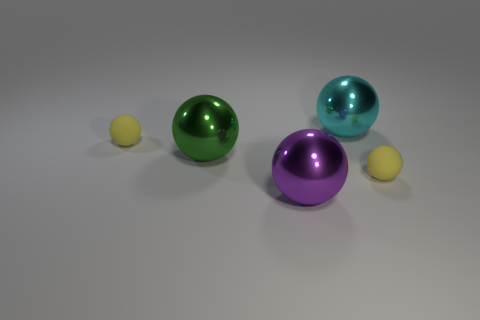There is a yellow matte thing on the right side of the purple metal thing; what is its shape?
Offer a terse response. Sphere. Does the yellow sphere that is to the left of the green ball have the same size as the cyan thing?
Give a very brief answer. No. There is a large purple thing; how many metal balls are on the right side of it?
Give a very brief answer. 1. Is the number of big green things that are to the right of the large cyan metal ball less than the number of tiny yellow rubber balls that are in front of the green ball?
Your answer should be compact. Yes. What number of cyan matte cylinders are there?
Offer a very short reply. 0. There is a tiny object that is to the right of the large green metallic object; what is its color?
Keep it short and to the point. Yellow. The purple metallic ball is what size?
Give a very brief answer. Large. What color is the matte ball that is on the right side of the metal object that is in front of the large green ball?
Your response must be concise. Yellow. How many balls are left of the big purple ball and behind the big green thing?
Make the answer very short. 1. What is the color of the metallic ball in front of the small yellow matte thing that is on the right side of the tiny object on the left side of the cyan metallic ball?
Your answer should be compact. Purple. 